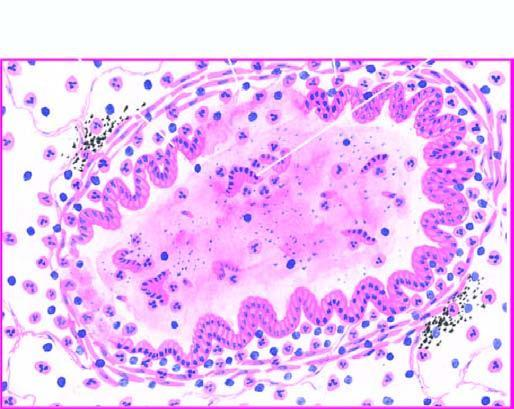what is the bronchial wall thickened and infiltrated by?
Answer the question using a single word or phrase. Acute and chronic inflammatory cells 